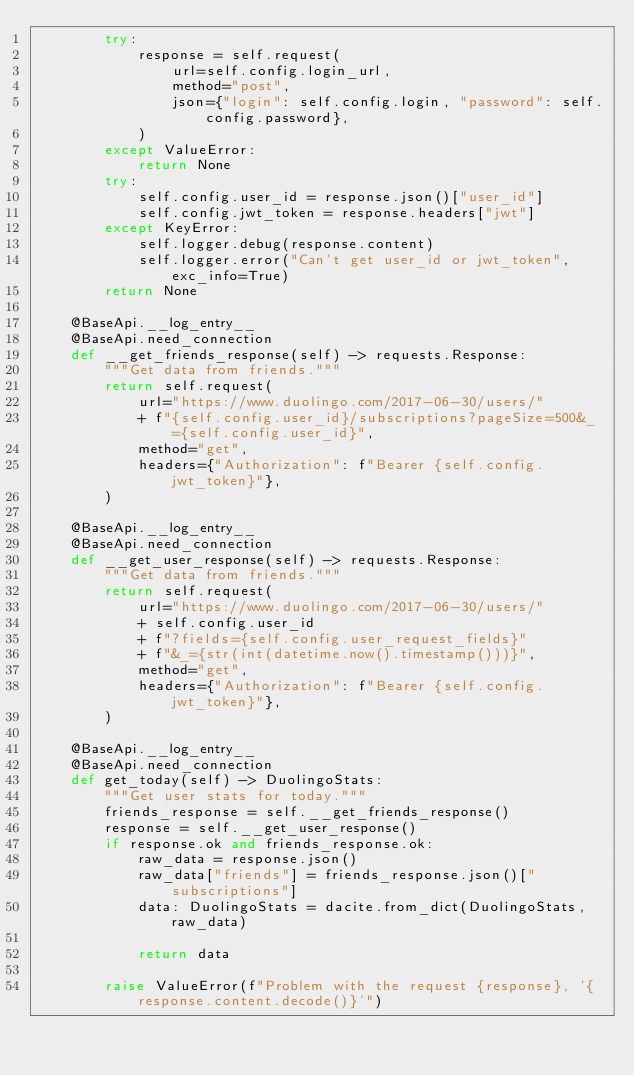<code> <loc_0><loc_0><loc_500><loc_500><_Python_>        try:
            response = self.request(
                url=self.config.login_url,
                method="post",
                json={"login": self.config.login, "password": self.config.password},
            )
        except ValueError:
            return None
        try:
            self.config.user_id = response.json()["user_id"]
            self.config.jwt_token = response.headers["jwt"]
        except KeyError:
            self.logger.debug(response.content)
            self.logger.error("Can't get user_id or jwt_token", exc_info=True)
        return None

    @BaseApi.__log_entry__
    @BaseApi.need_connection
    def __get_friends_response(self) -> requests.Response:
        """Get data from friends."""
        return self.request(
            url="https://www.duolingo.com/2017-06-30/users/"
            + f"{self.config.user_id}/subscriptions?pageSize=500&_={self.config.user_id}",
            method="get",
            headers={"Authorization": f"Bearer {self.config.jwt_token}"},
        )

    @BaseApi.__log_entry__
    @BaseApi.need_connection
    def __get_user_response(self) -> requests.Response:
        """Get data from friends."""
        return self.request(
            url="https://www.duolingo.com/2017-06-30/users/"
            + self.config.user_id
            + f"?fields={self.config.user_request_fields}"
            + f"&_={str(int(datetime.now().timestamp()))}",
            method="get",
            headers={"Authorization": f"Bearer {self.config.jwt_token}"},
        )

    @BaseApi.__log_entry__
    @BaseApi.need_connection
    def get_today(self) -> DuolingoStats:
        """Get user stats for today."""
        friends_response = self.__get_friends_response()
        response = self.__get_user_response()
        if response.ok and friends_response.ok:
            raw_data = response.json()
            raw_data["friends"] = friends_response.json()["subscriptions"]
            data: DuolingoStats = dacite.from_dict(DuolingoStats, raw_data)

            return data

        raise ValueError(f"Problem with the request {response}, '{response.content.decode()}'")
</code> 